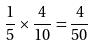Convert formula to latex. <formula><loc_0><loc_0><loc_500><loc_500>\frac { 1 } { 5 } \times \frac { 4 } { 1 0 } = \frac { 4 } { 5 0 }</formula> 